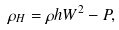Convert formula to latex. <formula><loc_0><loc_0><loc_500><loc_500>\rho _ { H } = \rho h W ^ { 2 } - P ,</formula> 